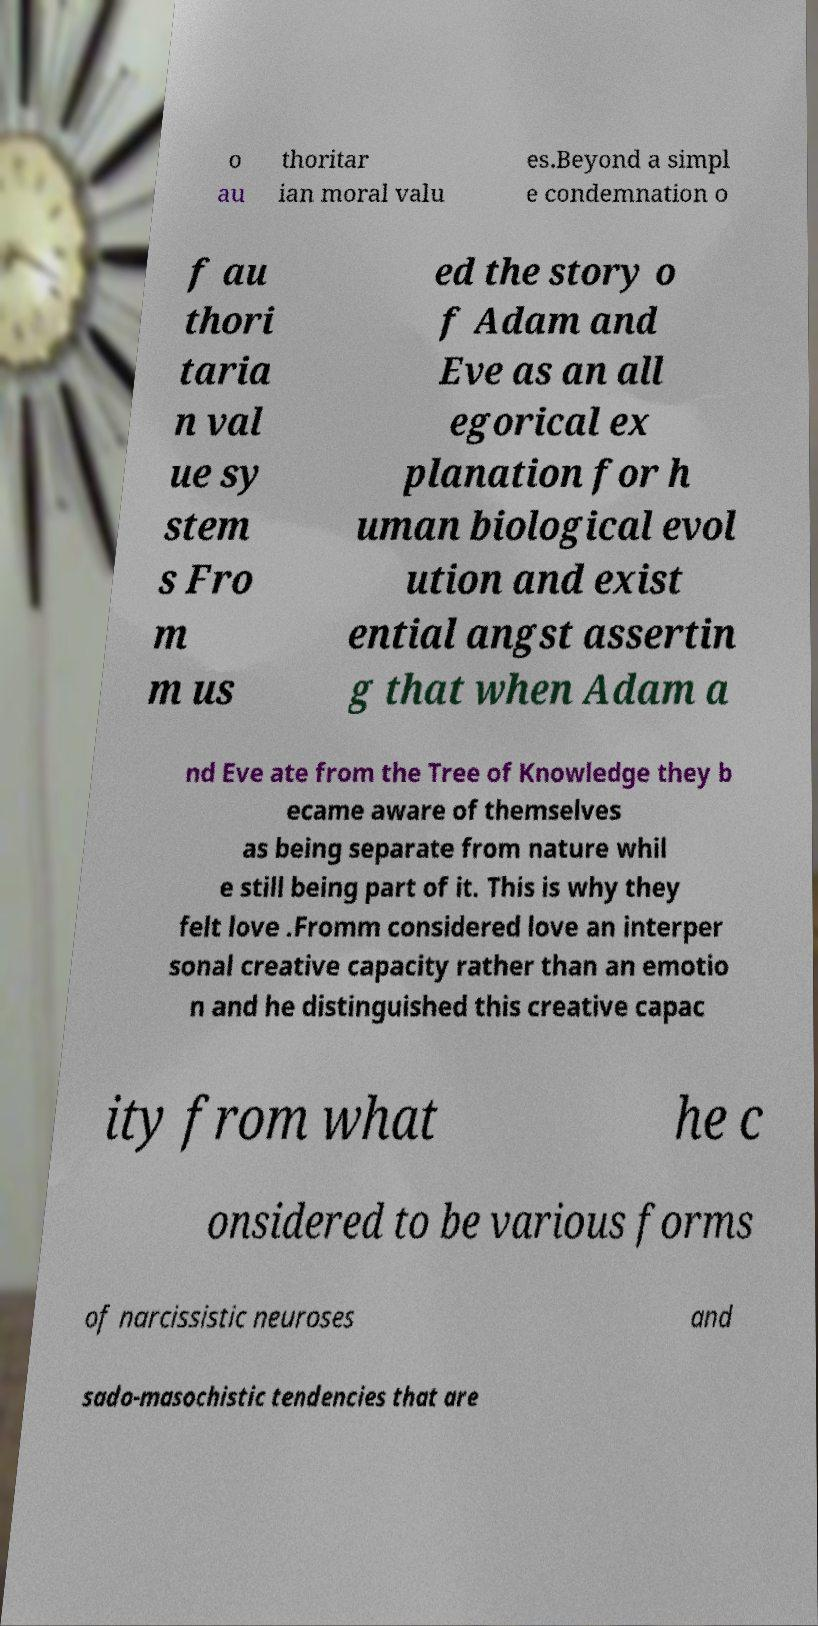Could you extract and type out the text from this image? o au thoritar ian moral valu es.Beyond a simpl e condemnation o f au thori taria n val ue sy stem s Fro m m us ed the story o f Adam and Eve as an all egorical ex planation for h uman biological evol ution and exist ential angst assertin g that when Adam a nd Eve ate from the Tree of Knowledge they b ecame aware of themselves as being separate from nature whil e still being part of it. This is why they felt love .Fromm considered love an interper sonal creative capacity rather than an emotio n and he distinguished this creative capac ity from what he c onsidered to be various forms of narcissistic neuroses and sado-masochistic tendencies that are 